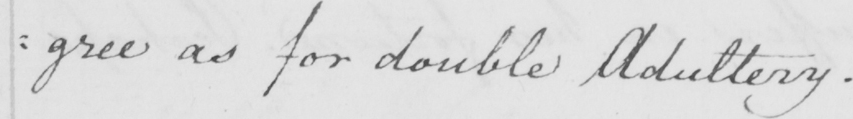Can you read and transcribe this handwriting? as for double Adultery . 